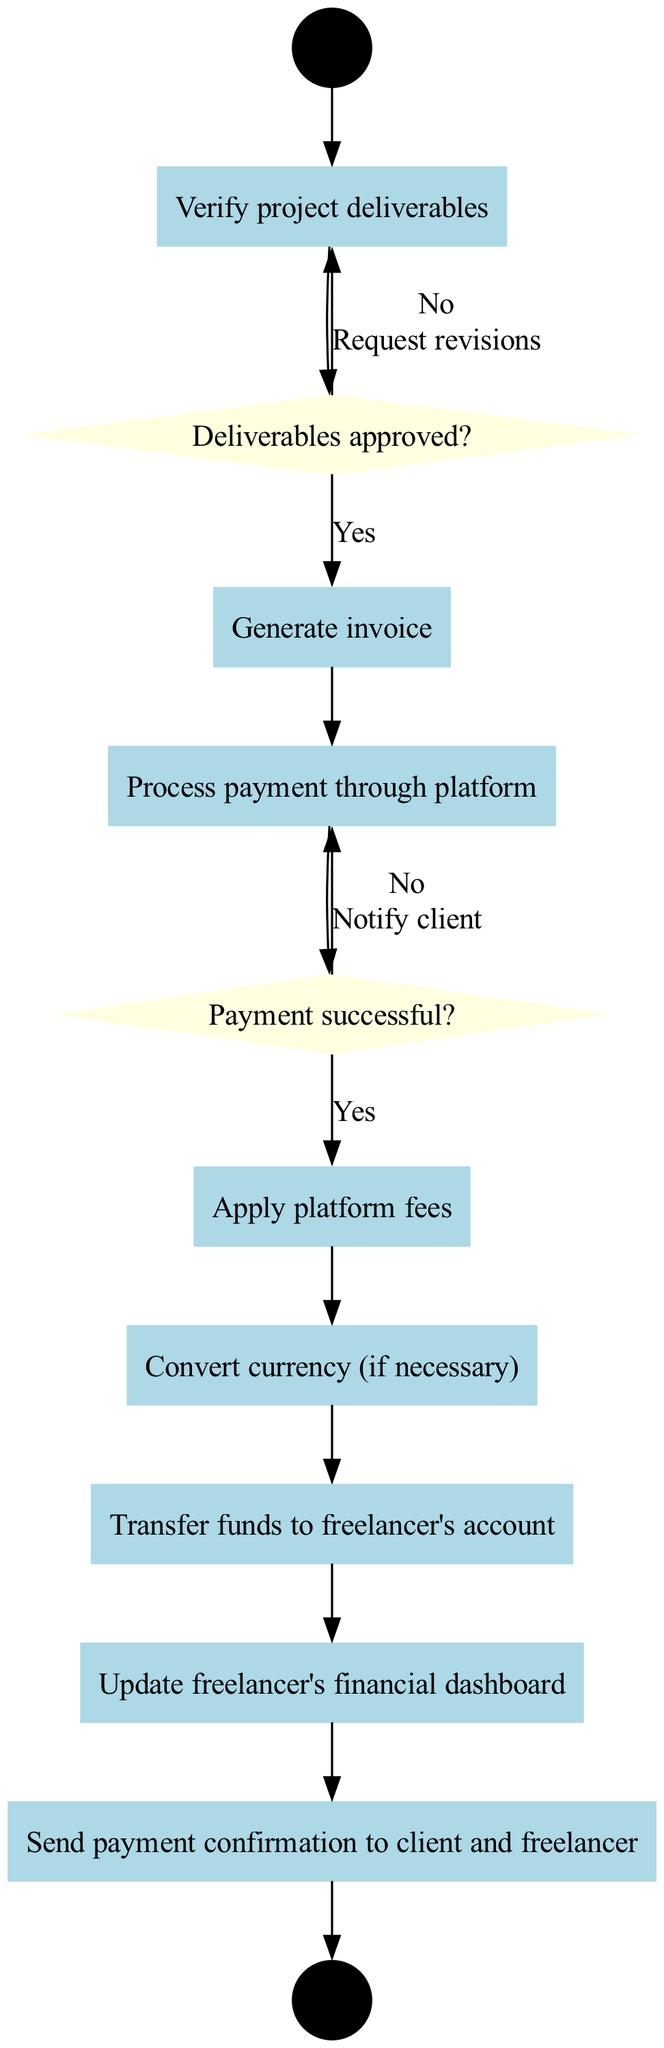What is the starting node of the diagram? The starting node is labeled "Project completion notification." Therefore, the diagram begins its process from this point.
Answer: Project completion notification How many decision nodes are present in the diagram? There are two decision nodes in the diagram based on the provided data—"Deliverables approved?" and "Payment successful?"
Answer: 2 What activity follows "Verify project deliverables"? The activity that immediately follows "Verify project deliverables" is to "Generate invoice," as indicated in the flow of the diagram.
Answer: Generate invoice What happens if the deliverables are not approved? If the deliverables are not approved, the diagram indicates that the next step is to "Request revisions." This is a response decision based on whether the deliverables meet the required standards.
Answer: Request revisions What is the final node of the diagram? The final node, which signifies the completion of the entire transaction process, is labeled "Transaction completed." Thus, it represents the end point of the workflow.
Answer: Transaction completed What action is taken when payment processing fails? When payment processing fails, the diagram specifies that the action taken is to "Notify client of payment failure." This is a critical part of the flow to inform all stakeholders.
Answer: Notify client of payment failure What activity is directly connected to the decision "Payment successful?" Directly connected to the decision "Payment successful?" is the activity "Apply platform fees." This indicates that a successful payment leads to fee processing.
Answer: Apply platform fees What does the diagram indicate happens after transferring funds to the freelancer's account? After transferring funds to the freelancer's account, the next step indicated is to "Update freelancer's financial dashboard." This ensures that the freelancer's records reflect the new transaction.
Answer: Update freelancer's financial dashboard How does a successful payment affect the workflow in the diagram? A successful payment leads to "Apply platform fees," indicating a sequence of actions that continue towards completing the financial transaction once payment is confirmed.
Answer: Apply platform fees 